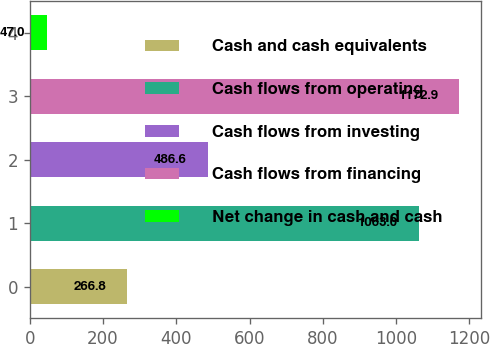<chart> <loc_0><loc_0><loc_500><loc_500><bar_chart><fcel>Cash and cash equivalents<fcel>Cash flows from operating<fcel>Cash flows from investing<fcel>Cash flows from financing<fcel>Net change in cash and cash<nl><fcel>266.8<fcel>1063<fcel>486.6<fcel>1172.9<fcel>47<nl></chart> 